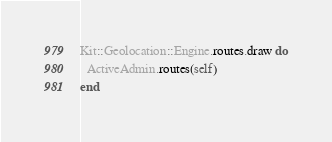<code> <loc_0><loc_0><loc_500><loc_500><_Ruby_>Kit::Geolocation::Engine.routes.draw do
  ActiveAdmin.routes(self)
end
</code> 